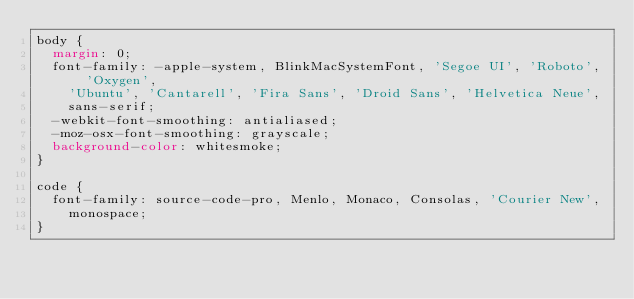Convert code to text. <code><loc_0><loc_0><loc_500><loc_500><_CSS_>body {
  margin: 0;
  font-family: -apple-system, BlinkMacSystemFont, 'Segoe UI', 'Roboto', 'Oxygen',
    'Ubuntu', 'Cantarell', 'Fira Sans', 'Droid Sans', 'Helvetica Neue',
    sans-serif;
  -webkit-font-smoothing: antialiased;
  -moz-osx-font-smoothing: grayscale;
  background-color: whitesmoke;
}

code {
  font-family: source-code-pro, Menlo, Monaco, Consolas, 'Courier New',
    monospace;
}
</code> 